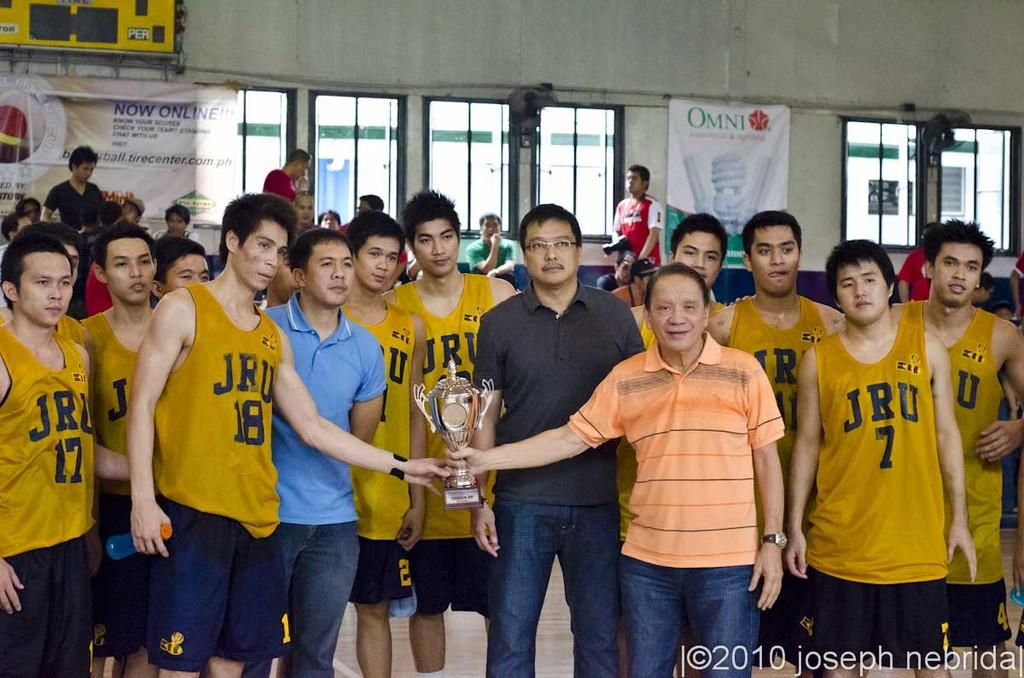<image>
Give a short and clear explanation of the subsequent image. A group of basketball players with jerseys that say JRU are holding a trophy. 